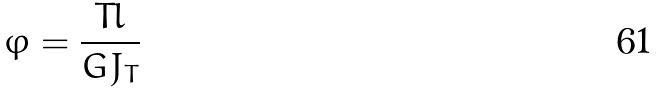<formula> <loc_0><loc_0><loc_500><loc_500>\varphi = \frac { T l } { G J _ { T } }</formula> 